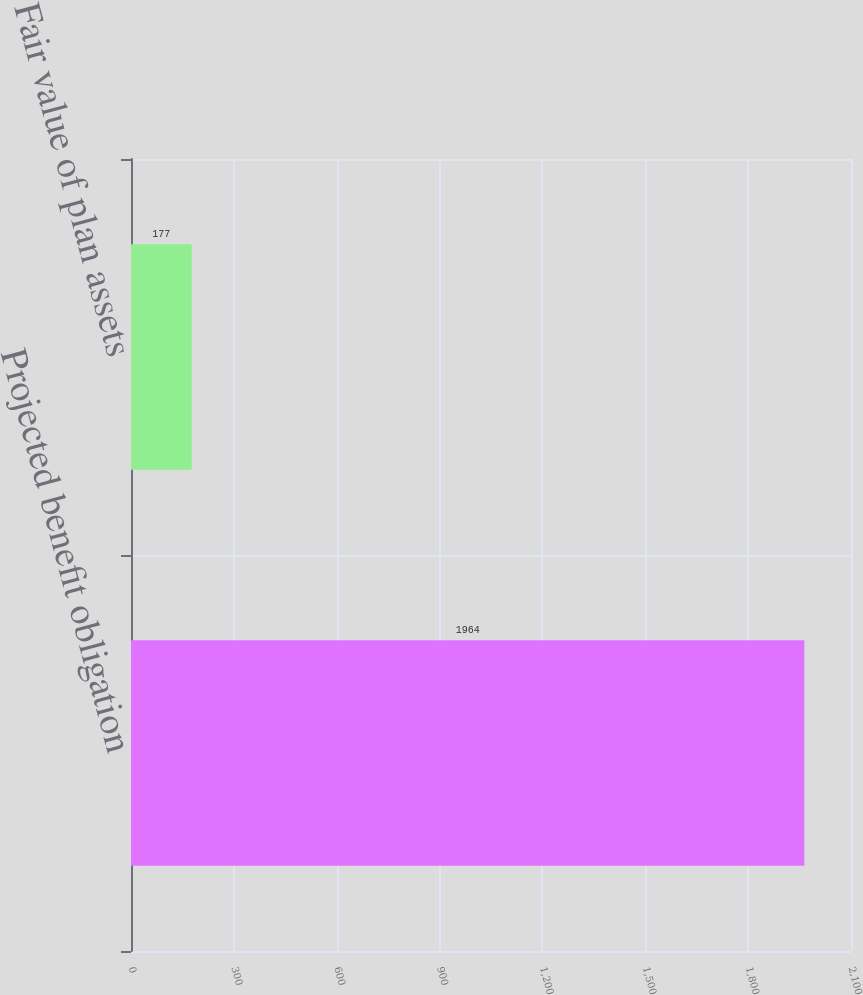Convert chart to OTSL. <chart><loc_0><loc_0><loc_500><loc_500><bar_chart><fcel>Projected benefit obligation<fcel>Fair value of plan assets<nl><fcel>1964<fcel>177<nl></chart> 